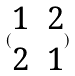<formula> <loc_0><loc_0><loc_500><loc_500>( \begin{matrix} 1 & 2 \\ 2 & 1 \end{matrix} )</formula> 